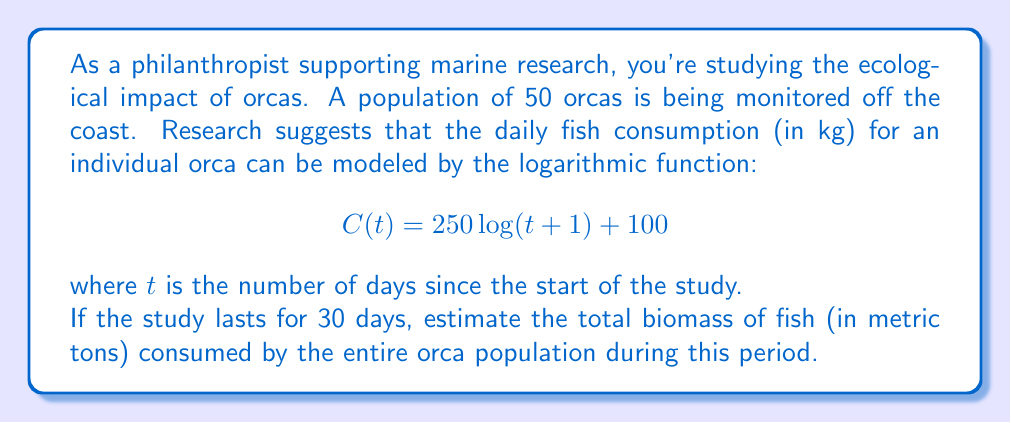Solve this math problem. Let's approach this step-by-step:

1) First, we need to find the total consumption for one orca over the 30-day period. We can do this by integrating the consumption function from day 0 to day 30:

   $\int_0^{30} C(t) dt = \int_0^{30} (250 \log(t+1) + 100) dt$

2) Integrate this function:
   
   $\int_0^{30} 250 \log(t+1) dt + \int_0^{30} 100 dt$
   
   $= 250[(t+1)(\log(t+1) - 1)]_0^{30} + 100t|_0^{30}$

3) Evaluate the integral:

   $= 250[(31(\log(31) - 1)) - (1(\log(1) - 1))] + 3000$
   
   $= 250[31(\log(31) - 1) + 1] + 3000$

4) Calculate this value (you can use a calculator):

   $\approx 250[31(3.4339 - 1) + 1] + 3000 \approx 21,721.39$ kg

5) This is for one orca. For 50 orcas, multiply by 50:

   $21,721.39 \times 50 = 1,086,069.5$ kg

6) Convert to metric tons by dividing by 1000:

   $1,086,069.5 / 1000 = 1,086.07$ metric tons
Answer: The estimated total biomass of fish consumed by the orca population over 30 days is approximately 1,086.07 metric tons. 